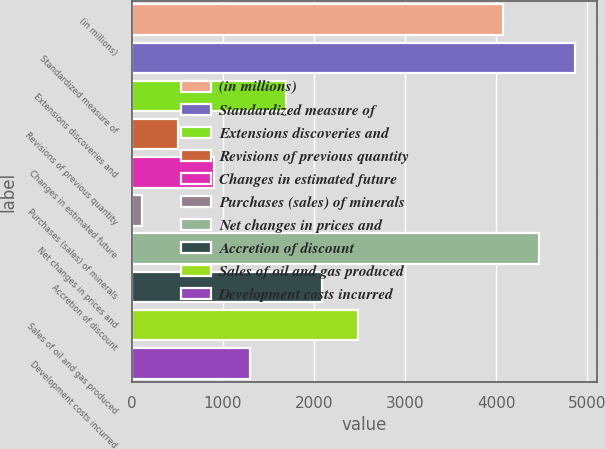Convert chart. <chart><loc_0><loc_0><loc_500><loc_500><bar_chart><fcel>(in millions)<fcel>Standardized measure of<fcel>Extensions discoveries and<fcel>Revisions of previous quantity<fcel>Changes in estimated future<fcel>Purchases (sales) of minerals<fcel>Net changes in prices and<fcel>Accretion of discount<fcel>Sales of oil and gas produced<fcel>Development costs incurred<nl><fcel>4074<fcel>4867.2<fcel>1694.4<fcel>504.6<fcel>901.2<fcel>108<fcel>4470.6<fcel>2091<fcel>2487.6<fcel>1297.8<nl></chart> 